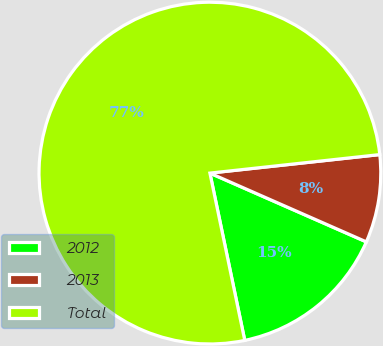Convert chart to OTSL. <chart><loc_0><loc_0><loc_500><loc_500><pie_chart><fcel>2012<fcel>2013<fcel>Total<nl><fcel>15.14%<fcel>8.32%<fcel>76.54%<nl></chart> 